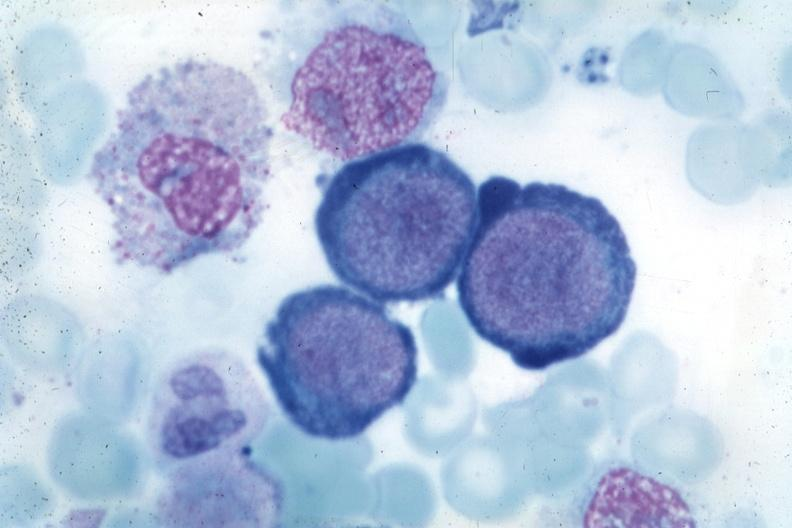does this image show wrights typical cells?
Answer the question using a single word or phrase. Yes 